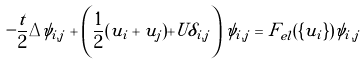<formula> <loc_0><loc_0><loc_500><loc_500>- \frac { t } { 2 } \Delta \psi _ { i , j } + \left ( \frac { 1 } { 2 } ( u _ { i } + u _ { j } ) + U \delta _ { i , j } \right ) \psi _ { i , j } = F _ { e l } ( \{ u _ { i } \} ) \psi _ { i , j }</formula> 